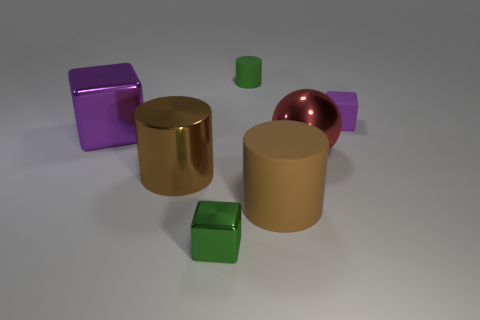Subtract 1 blocks. How many blocks are left? 2 Add 3 large red spheres. How many objects exist? 10 Subtract all spheres. How many objects are left? 6 Subtract 0 green spheres. How many objects are left? 7 Subtract all red metallic spheres. Subtract all red metallic balls. How many objects are left? 5 Add 6 small purple objects. How many small purple objects are left? 7 Add 5 rubber objects. How many rubber objects exist? 8 